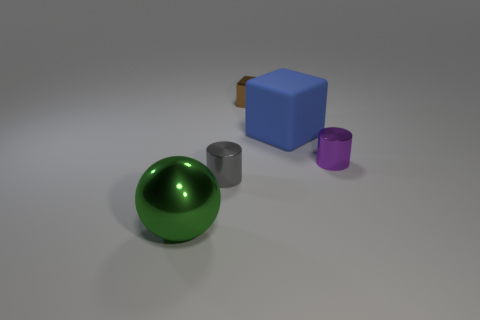What is the color of the large sphere that is made of the same material as the tiny brown cube?
Your answer should be compact. Green. Is there any other thing that is the same size as the gray shiny thing?
Your answer should be very brief. Yes. There is a gray metal cylinder; how many spheres are behind it?
Make the answer very short. 0. There is a small metal thing to the right of the shiny block; is its color the same as the large thing on the right side of the large green sphere?
Ensure brevity in your answer.  No. What color is the small metal object that is the same shape as the large blue matte thing?
Provide a succinct answer. Brown. Are there any other things that have the same shape as the brown metal object?
Keep it short and to the point. Yes. Does the big thing that is on the right side of the small gray metallic object have the same shape as the small shiny thing that is behind the big blue object?
Offer a very short reply. Yes. There is a brown cube; is it the same size as the block that is right of the tiny brown metallic object?
Provide a short and direct response. No. Is the number of shiny objects greater than the number of brown things?
Provide a short and direct response. Yes. Are the tiny cylinder that is to the left of the rubber object and the tiny thing behind the big blue cube made of the same material?
Offer a terse response. Yes. 